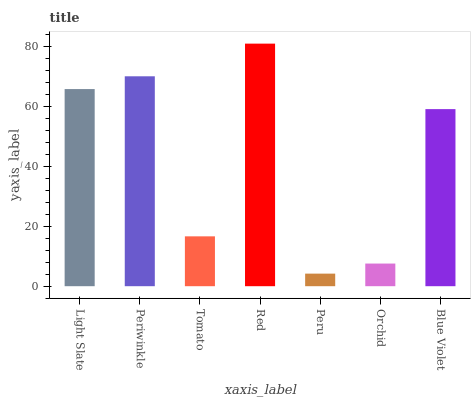Is Peru the minimum?
Answer yes or no. Yes. Is Red the maximum?
Answer yes or no. Yes. Is Periwinkle the minimum?
Answer yes or no. No. Is Periwinkle the maximum?
Answer yes or no. No. Is Periwinkle greater than Light Slate?
Answer yes or no. Yes. Is Light Slate less than Periwinkle?
Answer yes or no. Yes. Is Light Slate greater than Periwinkle?
Answer yes or no. No. Is Periwinkle less than Light Slate?
Answer yes or no. No. Is Blue Violet the high median?
Answer yes or no. Yes. Is Blue Violet the low median?
Answer yes or no. Yes. Is Periwinkle the high median?
Answer yes or no. No. Is Light Slate the low median?
Answer yes or no. No. 